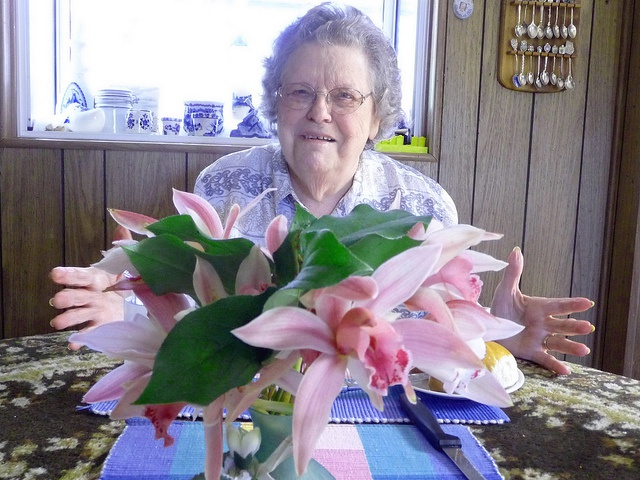Describe the objects in this image and their specific colors. I can see potted plant in gray, lavender, black, and pink tones, dining table in gray, black, darkgray, and lightblue tones, people in gray, lavender, and darkgray tones, vase in gray, darkgray, and teal tones, and spoon in gray and olive tones in this image. 